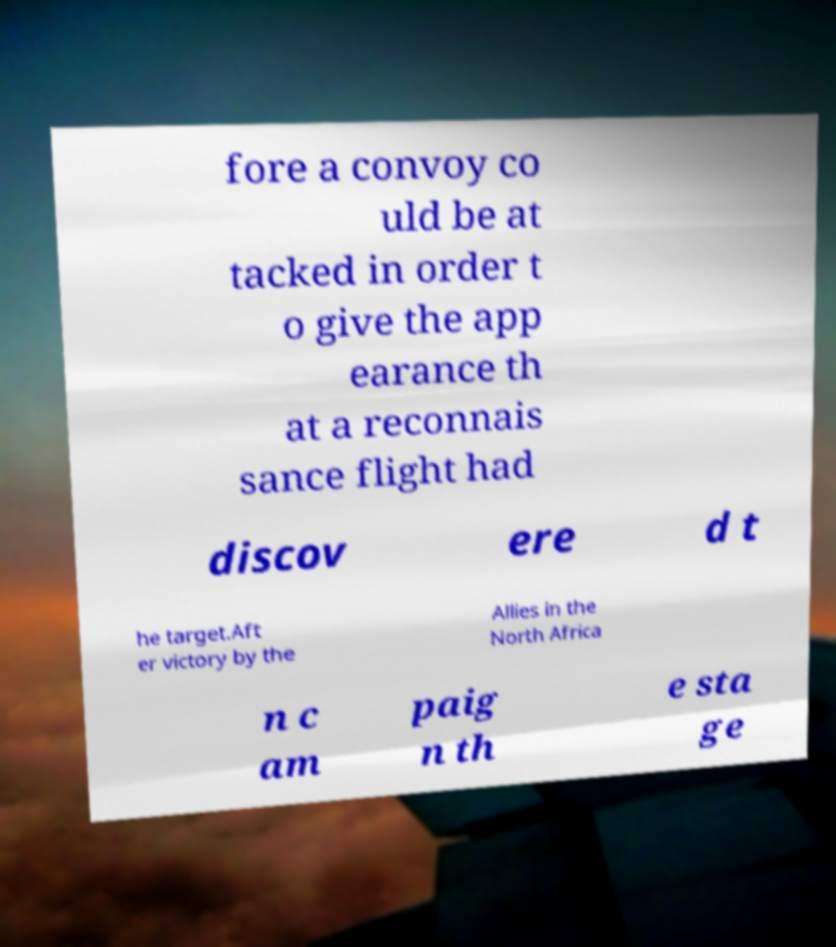For documentation purposes, I need the text within this image transcribed. Could you provide that? fore a convoy co uld be at tacked in order t o give the app earance th at a reconnais sance flight had discov ere d t he target.Aft er victory by the Allies in the North Africa n c am paig n th e sta ge 